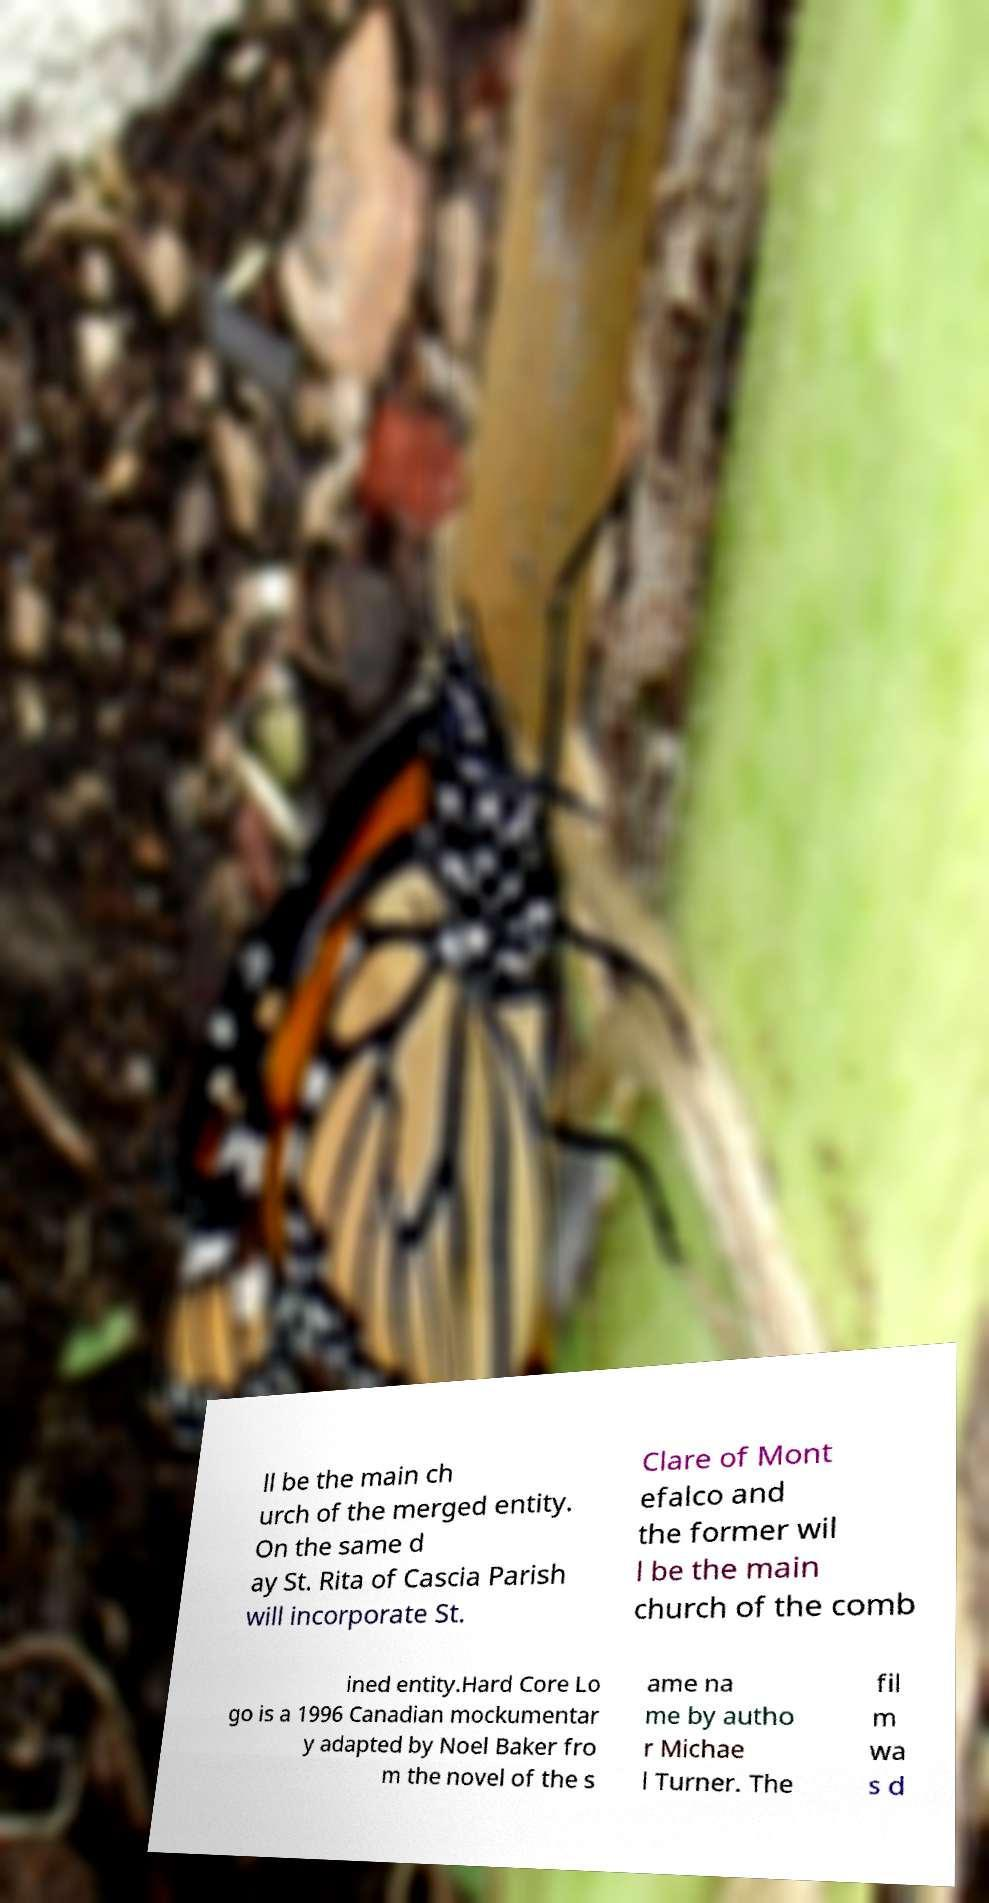Please identify and transcribe the text found in this image. ll be the main ch urch of the merged entity. On the same d ay St. Rita of Cascia Parish will incorporate St. Clare of Mont efalco and the former wil l be the main church of the comb ined entity.Hard Core Lo go is a 1996 Canadian mockumentar y adapted by Noel Baker fro m the novel of the s ame na me by autho r Michae l Turner. The fil m wa s d 